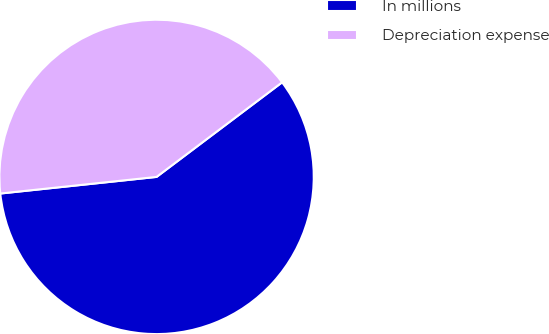<chart> <loc_0><loc_0><loc_500><loc_500><pie_chart><fcel>In millions<fcel>Depreciation expense<nl><fcel>58.59%<fcel>41.41%<nl></chart> 